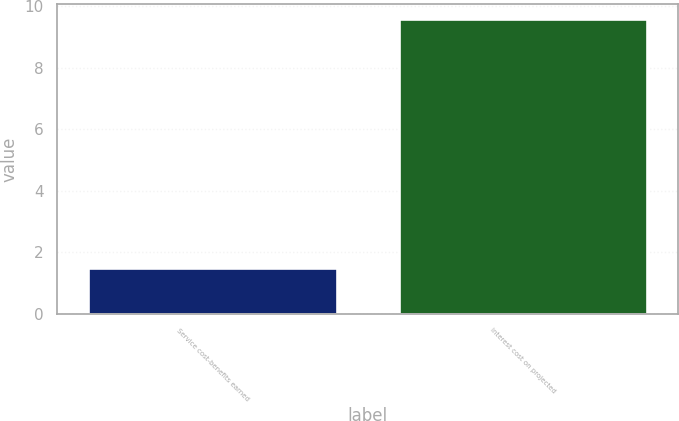Convert chart. <chart><loc_0><loc_0><loc_500><loc_500><bar_chart><fcel>Service cost-benefits earned<fcel>interest cost on projected<nl><fcel>1.5<fcel>9.6<nl></chart> 